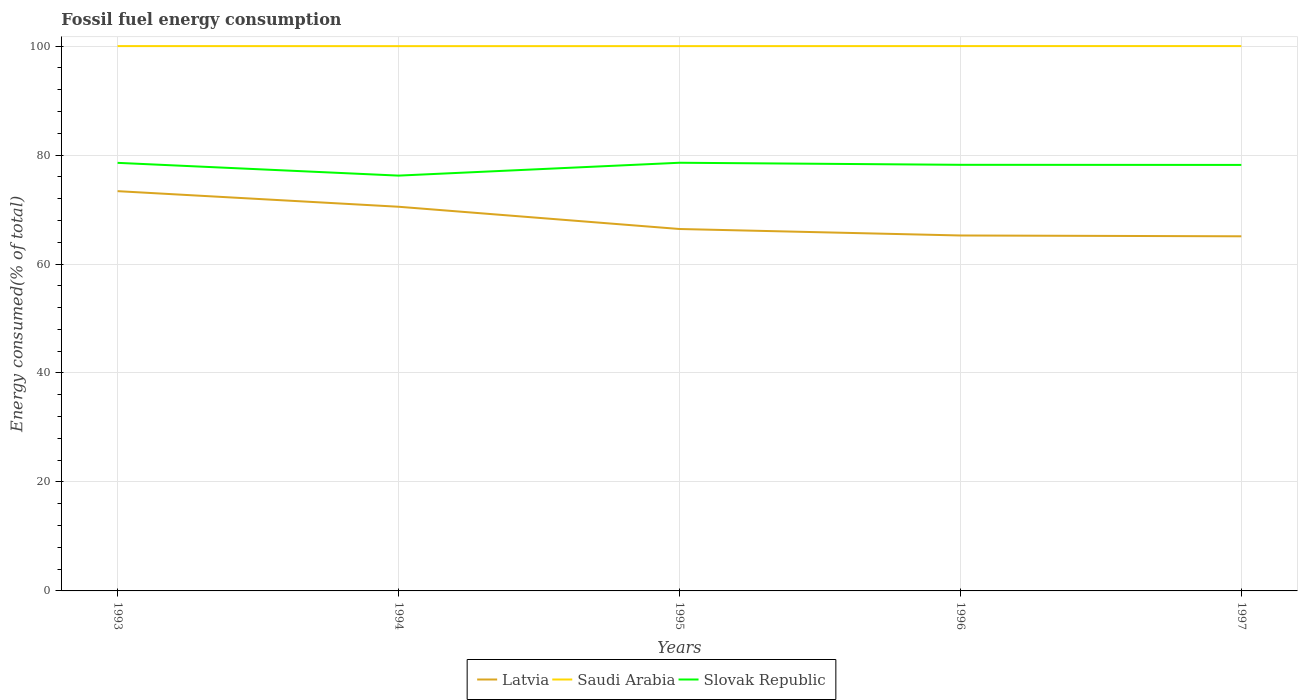Is the number of lines equal to the number of legend labels?
Ensure brevity in your answer.  Yes. Across all years, what is the maximum percentage of energy consumed in Latvia?
Ensure brevity in your answer.  65.08. In which year was the percentage of energy consumed in Saudi Arabia maximum?
Provide a short and direct response. 1994. What is the total percentage of energy consumed in Saudi Arabia in the graph?
Make the answer very short. -0.01. What is the difference between the highest and the second highest percentage of energy consumed in Saudi Arabia?
Make the answer very short. 0.01. Is the percentage of energy consumed in Saudi Arabia strictly greater than the percentage of energy consumed in Latvia over the years?
Your answer should be very brief. No. How many lines are there?
Keep it short and to the point. 3. What is the difference between two consecutive major ticks on the Y-axis?
Offer a terse response. 20. How many legend labels are there?
Your response must be concise. 3. How are the legend labels stacked?
Your response must be concise. Horizontal. What is the title of the graph?
Your response must be concise. Fossil fuel energy consumption. What is the label or title of the Y-axis?
Keep it short and to the point. Energy consumed(% of total). What is the Energy consumed(% of total) in Latvia in 1993?
Give a very brief answer. 73.37. What is the Energy consumed(% of total) of Saudi Arabia in 1993?
Your answer should be very brief. 99.99. What is the Energy consumed(% of total) of Slovak Republic in 1993?
Your answer should be very brief. 78.57. What is the Energy consumed(% of total) in Latvia in 1994?
Make the answer very short. 70.51. What is the Energy consumed(% of total) of Saudi Arabia in 1994?
Keep it short and to the point. 99.98. What is the Energy consumed(% of total) of Slovak Republic in 1994?
Give a very brief answer. 76.22. What is the Energy consumed(% of total) in Latvia in 1995?
Provide a succinct answer. 66.43. What is the Energy consumed(% of total) of Saudi Arabia in 1995?
Provide a succinct answer. 99.99. What is the Energy consumed(% of total) of Slovak Republic in 1995?
Provide a short and direct response. 78.58. What is the Energy consumed(% of total) in Latvia in 1996?
Make the answer very short. 65.23. What is the Energy consumed(% of total) in Saudi Arabia in 1996?
Offer a very short reply. 100. What is the Energy consumed(% of total) of Slovak Republic in 1996?
Offer a terse response. 78.2. What is the Energy consumed(% of total) of Latvia in 1997?
Make the answer very short. 65.08. What is the Energy consumed(% of total) of Saudi Arabia in 1997?
Your answer should be very brief. 100. What is the Energy consumed(% of total) of Slovak Republic in 1997?
Ensure brevity in your answer.  78.19. Across all years, what is the maximum Energy consumed(% of total) of Latvia?
Your answer should be very brief. 73.37. Across all years, what is the maximum Energy consumed(% of total) in Saudi Arabia?
Your response must be concise. 100. Across all years, what is the maximum Energy consumed(% of total) in Slovak Republic?
Offer a very short reply. 78.58. Across all years, what is the minimum Energy consumed(% of total) in Latvia?
Your answer should be very brief. 65.08. Across all years, what is the minimum Energy consumed(% of total) of Saudi Arabia?
Keep it short and to the point. 99.98. Across all years, what is the minimum Energy consumed(% of total) in Slovak Republic?
Give a very brief answer. 76.22. What is the total Energy consumed(% of total) of Latvia in the graph?
Offer a very short reply. 340.62. What is the total Energy consumed(% of total) of Saudi Arabia in the graph?
Keep it short and to the point. 499.96. What is the total Energy consumed(% of total) of Slovak Republic in the graph?
Your response must be concise. 389.76. What is the difference between the Energy consumed(% of total) of Latvia in 1993 and that in 1994?
Provide a succinct answer. 2.86. What is the difference between the Energy consumed(% of total) in Saudi Arabia in 1993 and that in 1994?
Give a very brief answer. 0.01. What is the difference between the Energy consumed(% of total) in Slovak Republic in 1993 and that in 1994?
Provide a succinct answer. 2.34. What is the difference between the Energy consumed(% of total) in Latvia in 1993 and that in 1995?
Your answer should be very brief. 6.95. What is the difference between the Energy consumed(% of total) in Saudi Arabia in 1993 and that in 1995?
Your response must be concise. 0.01. What is the difference between the Energy consumed(% of total) of Slovak Republic in 1993 and that in 1995?
Keep it short and to the point. -0.02. What is the difference between the Energy consumed(% of total) in Latvia in 1993 and that in 1996?
Provide a short and direct response. 8.14. What is the difference between the Energy consumed(% of total) in Saudi Arabia in 1993 and that in 1996?
Provide a short and direct response. -0. What is the difference between the Energy consumed(% of total) in Slovak Republic in 1993 and that in 1996?
Ensure brevity in your answer.  0.36. What is the difference between the Energy consumed(% of total) in Latvia in 1993 and that in 1997?
Make the answer very short. 8.29. What is the difference between the Energy consumed(% of total) of Saudi Arabia in 1993 and that in 1997?
Offer a terse response. -0. What is the difference between the Energy consumed(% of total) in Slovak Republic in 1993 and that in 1997?
Keep it short and to the point. 0.38. What is the difference between the Energy consumed(% of total) in Latvia in 1994 and that in 1995?
Your answer should be compact. 4.08. What is the difference between the Energy consumed(% of total) in Saudi Arabia in 1994 and that in 1995?
Offer a terse response. -0. What is the difference between the Energy consumed(% of total) in Slovak Republic in 1994 and that in 1995?
Offer a very short reply. -2.36. What is the difference between the Energy consumed(% of total) of Latvia in 1994 and that in 1996?
Give a very brief answer. 5.27. What is the difference between the Energy consumed(% of total) of Saudi Arabia in 1994 and that in 1996?
Provide a short and direct response. -0.01. What is the difference between the Energy consumed(% of total) of Slovak Republic in 1994 and that in 1996?
Offer a terse response. -1.98. What is the difference between the Energy consumed(% of total) of Latvia in 1994 and that in 1997?
Your answer should be very brief. 5.42. What is the difference between the Energy consumed(% of total) in Saudi Arabia in 1994 and that in 1997?
Provide a succinct answer. -0.01. What is the difference between the Energy consumed(% of total) in Slovak Republic in 1994 and that in 1997?
Offer a very short reply. -1.96. What is the difference between the Energy consumed(% of total) of Latvia in 1995 and that in 1996?
Give a very brief answer. 1.19. What is the difference between the Energy consumed(% of total) of Saudi Arabia in 1995 and that in 1996?
Keep it short and to the point. -0.01. What is the difference between the Energy consumed(% of total) of Slovak Republic in 1995 and that in 1996?
Provide a short and direct response. 0.38. What is the difference between the Energy consumed(% of total) in Latvia in 1995 and that in 1997?
Your response must be concise. 1.34. What is the difference between the Energy consumed(% of total) in Saudi Arabia in 1995 and that in 1997?
Make the answer very short. -0.01. What is the difference between the Energy consumed(% of total) in Slovak Republic in 1995 and that in 1997?
Your response must be concise. 0.4. What is the difference between the Energy consumed(% of total) in Latvia in 1996 and that in 1997?
Keep it short and to the point. 0.15. What is the difference between the Energy consumed(% of total) of Saudi Arabia in 1996 and that in 1997?
Provide a short and direct response. -0. What is the difference between the Energy consumed(% of total) in Slovak Republic in 1996 and that in 1997?
Offer a very short reply. 0.02. What is the difference between the Energy consumed(% of total) of Latvia in 1993 and the Energy consumed(% of total) of Saudi Arabia in 1994?
Ensure brevity in your answer.  -26.61. What is the difference between the Energy consumed(% of total) in Latvia in 1993 and the Energy consumed(% of total) in Slovak Republic in 1994?
Provide a short and direct response. -2.85. What is the difference between the Energy consumed(% of total) in Saudi Arabia in 1993 and the Energy consumed(% of total) in Slovak Republic in 1994?
Your response must be concise. 23.77. What is the difference between the Energy consumed(% of total) of Latvia in 1993 and the Energy consumed(% of total) of Saudi Arabia in 1995?
Provide a succinct answer. -26.62. What is the difference between the Energy consumed(% of total) in Latvia in 1993 and the Energy consumed(% of total) in Slovak Republic in 1995?
Provide a succinct answer. -5.21. What is the difference between the Energy consumed(% of total) in Saudi Arabia in 1993 and the Energy consumed(% of total) in Slovak Republic in 1995?
Give a very brief answer. 21.41. What is the difference between the Energy consumed(% of total) of Latvia in 1993 and the Energy consumed(% of total) of Saudi Arabia in 1996?
Give a very brief answer. -26.62. What is the difference between the Energy consumed(% of total) in Latvia in 1993 and the Energy consumed(% of total) in Slovak Republic in 1996?
Make the answer very short. -4.83. What is the difference between the Energy consumed(% of total) of Saudi Arabia in 1993 and the Energy consumed(% of total) of Slovak Republic in 1996?
Make the answer very short. 21.79. What is the difference between the Energy consumed(% of total) in Latvia in 1993 and the Energy consumed(% of total) in Saudi Arabia in 1997?
Your answer should be compact. -26.62. What is the difference between the Energy consumed(% of total) in Latvia in 1993 and the Energy consumed(% of total) in Slovak Republic in 1997?
Provide a short and direct response. -4.81. What is the difference between the Energy consumed(% of total) in Saudi Arabia in 1993 and the Energy consumed(% of total) in Slovak Republic in 1997?
Offer a very short reply. 21.81. What is the difference between the Energy consumed(% of total) in Latvia in 1994 and the Energy consumed(% of total) in Saudi Arabia in 1995?
Your answer should be compact. -29.48. What is the difference between the Energy consumed(% of total) in Latvia in 1994 and the Energy consumed(% of total) in Slovak Republic in 1995?
Offer a terse response. -8.07. What is the difference between the Energy consumed(% of total) in Saudi Arabia in 1994 and the Energy consumed(% of total) in Slovak Republic in 1995?
Make the answer very short. 21.4. What is the difference between the Energy consumed(% of total) of Latvia in 1994 and the Energy consumed(% of total) of Saudi Arabia in 1996?
Offer a very short reply. -29.49. What is the difference between the Energy consumed(% of total) in Latvia in 1994 and the Energy consumed(% of total) in Slovak Republic in 1996?
Provide a succinct answer. -7.7. What is the difference between the Energy consumed(% of total) of Saudi Arabia in 1994 and the Energy consumed(% of total) of Slovak Republic in 1996?
Keep it short and to the point. 21.78. What is the difference between the Energy consumed(% of total) of Latvia in 1994 and the Energy consumed(% of total) of Saudi Arabia in 1997?
Give a very brief answer. -29.49. What is the difference between the Energy consumed(% of total) of Latvia in 1994 and the Energy consumed(% of total) of Slovak Republic in 1997?
Your answer should be compact. -7.68. What is the difference between the Energy consumed(% of total) in Saudi Arabia in 1994 and the Energy consumed(% of total) in Slovak Republic in 1997?
Provide a short and direct response. 21.8. What is the difference between the Energy consumed(% of total) of Latvia in 1995 and the Energy consumed(% of total) of Saudi Arabia in 1996?
Your answer should be compact. -33.57. What is the difference between the Energy consumed(% of total) in Latvia in 1995 and the Energy consumed(% of total) in Slovak Republic in 1996?
Give a very brief answer. -11.78. What is the difference between the Energy consumed(% of total) of Saudi Arabia in 1995 and the Energy consumed(% of total) of Slovak Republic in 1996?
Ensure brevity in your answer.  21.78. What is the difference between the Energy consumed(% of total) of Latvia in 1995 and the Energy consumed(% of total) of Saudi Arabia in 1997?
Give a very brief answer. -33.57. What is the difference between the Energy consumed(% of total) in Latvia in 1995 and the Energy consumed(% of total) in Slovak Republic in 1997?
Ensure brevity in your answer.  -11.76. What is the difference between the Energy consumed(% of total) of Saudi Arabia in 1995 and the Energy consumed(% of total) of Slovak Republic in 1997?
Ensure brevity in your answer.  21.8. What is the difference between the Energy consumed(% of total) in Latvia in 1996 and the Energy consumed(% of total) in Saudi Arabia in 1997?
Provide a succinct answer. -34.76. What is the difference between the Energy consumed(% of total) of Latvia in 1996 and the Energy consumed(% of total) of Slovak Republic in 1997?
Offer a terse response. -12.95. What is the difference between the Energy consumed(% of total) in Saudi Arabia in 1996 and the Energy consumed(% of total) in Slovak Republic in 1997?
Offer a terse response. 21.81. What is the average Energy consumed(% of total) of Latvia per year?
Provide a short and direct response. 68.12. What is the average Energy consumed(% of total) of Saudi Arabia per year?
Ensure brevity in your answer.  99.99. What is the average Energy consumed(% of total) of Slovak Republic per year?
Ensure brevity in your answer.  77.95. In the year 1993, what is the difference between the Energy consumed(% of total) in Latvia and Energy consumed(% of total) in Saudi Arabia?
Keep it short and to the point. -26.62. In the year 1993, what is the difference between the Energy consumed(% of total) in Latvia and Energy consumed(% of total) in Slovak Republic?
Offer a very short reply. -5.2. In the year 1993, what is the difference between the Energy consumed(% of total) in Saudi Arabia and Energy consumed(% of total) in Slovak Republic?
Your answer should be very brief. 21.43. In the year 1994, what is the difference between the Energy consumed(% of total) in Latvia and Energy consumed(% of total) in Saudi Arabia?
Ensure brevity in your answer.  -29.48. In the year 1994, what is the difference between the Energy consumed(% of total) in Latvia and Energy consumed(% of total) in Slovak Republic?
Ensure brevity in your answer.  -5.71. In the year 1994, what is the difference between the Energy consumed(% of total) of Saudi Arabia and Energy consumed(% of total) of Slovak Republic?
Offer a very short reply. 23.76. In the year 1995, what is the difference between the Energy consumed(% of total) in Latvia and Energy consumed(% of total) in Saudi Arabia?
Provide a short and direct response. -33.56. In the year 1995, what is the difference between the Energy consumed(% of total) in Latvia and Energy consumed(% of total) in Slovak Republic?
Provide a short and direct response. -12.16. In the year 1995, what is the difference between the Energy consumed(% of total) of Saudi Arabia and Energy consumed(% of total) of Slovak Republic?
Give a very brief answer. 21.4. In the year 1996, what is the difference between the Energy consumed(% of total) of Latvia and Energy consumed(% of total) of Saudi Arabia?
Ensure brevity in your answer.  -34.76. In the year 1996, what is the difference between the Energy consumed(% of total) in Latvia and Energy consumed(% of total) in Slovak Republic?
Make the answer very short. -12.97. In the year 1996, what is the difference between the Energy consumed(% of total) in Saudi Arabia and Energy consumed(% of total) in Slovak Republic?
Offer a very short reply. 21.79. In the year 1997, what is the difference between the Energy consumed(% of total) in Latvia and Energy consumed(% of total) in Saudi Arabia?
Offer a terse response. -34.91. In the year 1997, what is the difference between the Energy consumed(% of total) in Latvia and Energy consumed(% of total) in Slovak Republic?
Provide a succinct answer. -13.1. In the year 1997, what is the difference between the Energy consumed(% of total) in Saudi Arabia and Energy consumed(% of total) in Slovak Republic?
Provide a succinct answer. 21.81. What is the ratio of the Energy consumed(% of total) of Latvia in 1993 to that in 1994?
Your response must be concise. 1.04. What is the ratio of the Energy consumed(% of total) of Saudi Arabia in 1993 to that in 1994?
Give a very brief answer. 1. What is the ratio of the Energy consumed(% of total) in Slovak Republic in 1993 to that in 1994?
Offer a terse response. 1.03. What is the ratio of the Energy consumed(% of total) in Latvia in 1993 to that in 1995?
Keep it short and to the point. 1.1. What is the ratio of the Energy consumed(% of total) in Saudi Arabia in 1993 to that in 1995?
Offer a terse response. 1. What is the ratio of the Energy consumed(% of total) of Slovak Republic in 1993 to that in 1995?
Keep it short and to the point. 1. What is the ratio of the Energy consumed(% of total) of Latvia in 1993 to that in 1996?
Give a very brief answer. 1.12. What is the ratio of the Energy consumed(% of total) in Slovak Republic in 1993 to that in 1996?
Provide a short and direct response. 1. What is the ratio of the Energy consumed(% of total) of Latvia in 1993 to that in 1997?
Offer a terse response. 1.13. What is the ratio of the Energy consumed(% of total) in Slovak Republic in 1993 to that in 1997?
Ensure brevity in your answer.  1. What is the ratio of the Energy consumed(% of total) in Latvia in 1994 to that in 1995?
Your answer should be compact. 1.06. What is the ratio of the Energy consumed(% of total) in Slovak Republic in 1994 to that in 1995?
Make the answer very short. 0.97. What is the ratio of the Energy consumed(% of total) in Latvia in 1994 to that in 1996?
Offer a very short reply. 1.08. What is the ratio of the Energy consumed(% of total) of Slovak Republic in 1994 to that in 1996?
Offer a very short reply. 0.97. What is the ratio of the Energy consumed(% of total) in Saudi Arabia in 1994 to that in 1997?
Give a very brief answer. 1. What is the ratio of the Energy consumed(% of total) of Slovak Republic in 1994 to that in 1997?
Your answer should be very brief. 0.97. What is the ratio of the Energy consumed(% of total) of Latvia in 1995 to that in 1996?
Ensure brevity in your answer.  1.02. What is the ratio of the Energy consumed(% of total) in Latvia in 1995 to that in 1997?
Provide a short and direct response. 1.02. What is the difference between the highest and the second highest Energy consumed(% of total) of Latvia?
Offer a terse response. 2.86. What is the difference between the highest and the second highest Energy consumed(% of total) of Slovak Republic?
Give a very brief answer. 0.02. What is the difference between the highest and the lowest Energy consumed(% of total) of Latvia?
Offer a very short reply. 8.29. What is the difference between the highest and the lowest Energy consumed(% of total) in Saudi Arabia?
Offer a terse response. 0.01. What is the difference between the highest and the lowest Energy consumed(% of total) of Slovak Republic?
Ensure brevity in your answer.  2.36. 